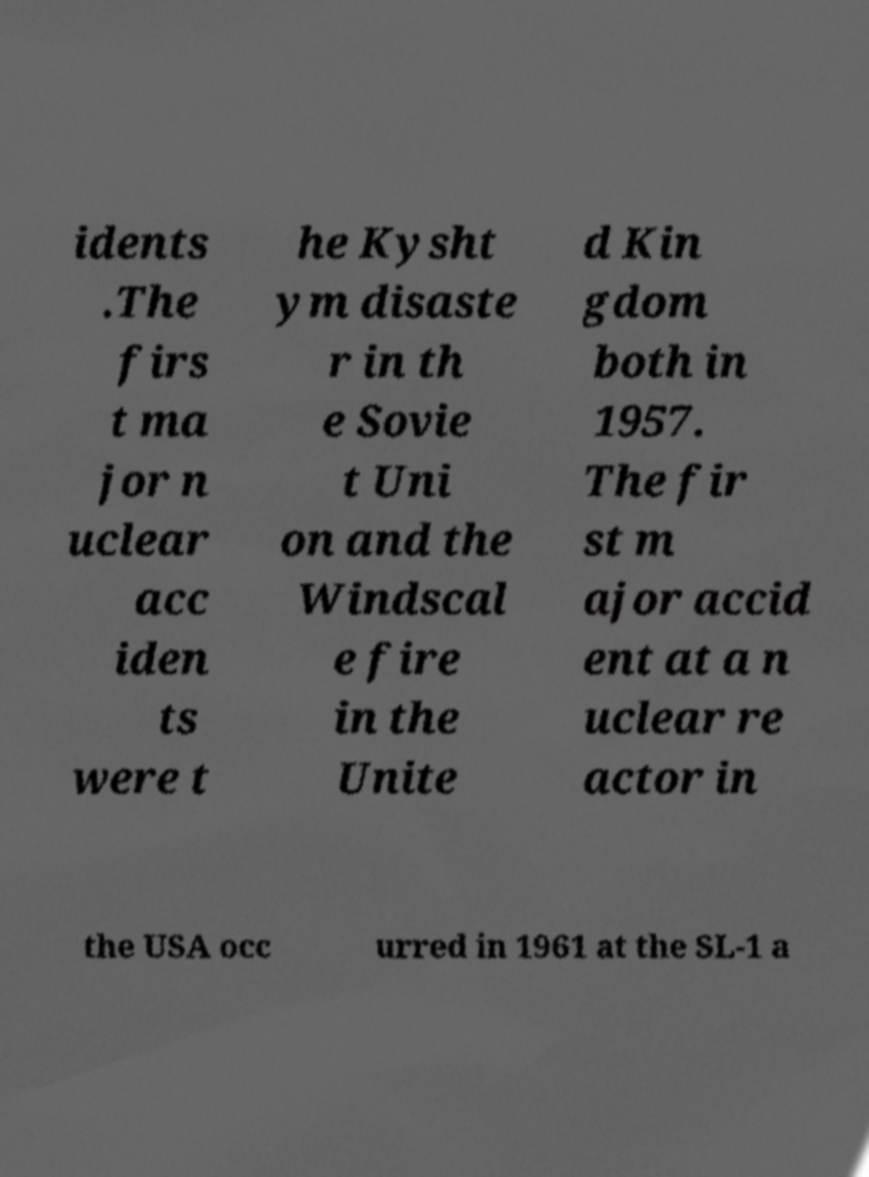Could you extract and type out the text from this image? idents .The firs t ma jor n uclear acc iden ts were t he Kysht ym disaste r in th e Sovie t Uni on and the Windscal e fire in the Unite d Kin gdom both in 1957. The fir st m ajor accid ent at a n uclear re actor in the USA occ urred in 1961 at the SL-1 a 